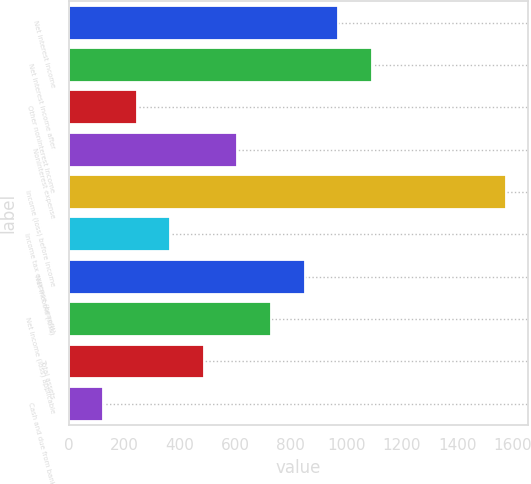Convert chart. <chart><loc_0><loc_0><loc_500><loc_500><bar_chart><fcel>Net interest income<fcel>Net interest income after<fcel>Other noninterest income<fcel>Noninterest expense<fcel>Income (loss) before income<fcel>Income tax expense (benefit)<fcel>Net income (loss)<fcel>Net income (loss) applicable<fcel>Total assets<fcel>Cash and due from banks<nl><fcel>970.8<fcel>1091.9<fcel>244.2<fcel>607.5<fcel>1576.3<fcel>365.3<fcel>849.7<fcel>728.6<fcel>486.4<fcel>123.1<nl></chart> 